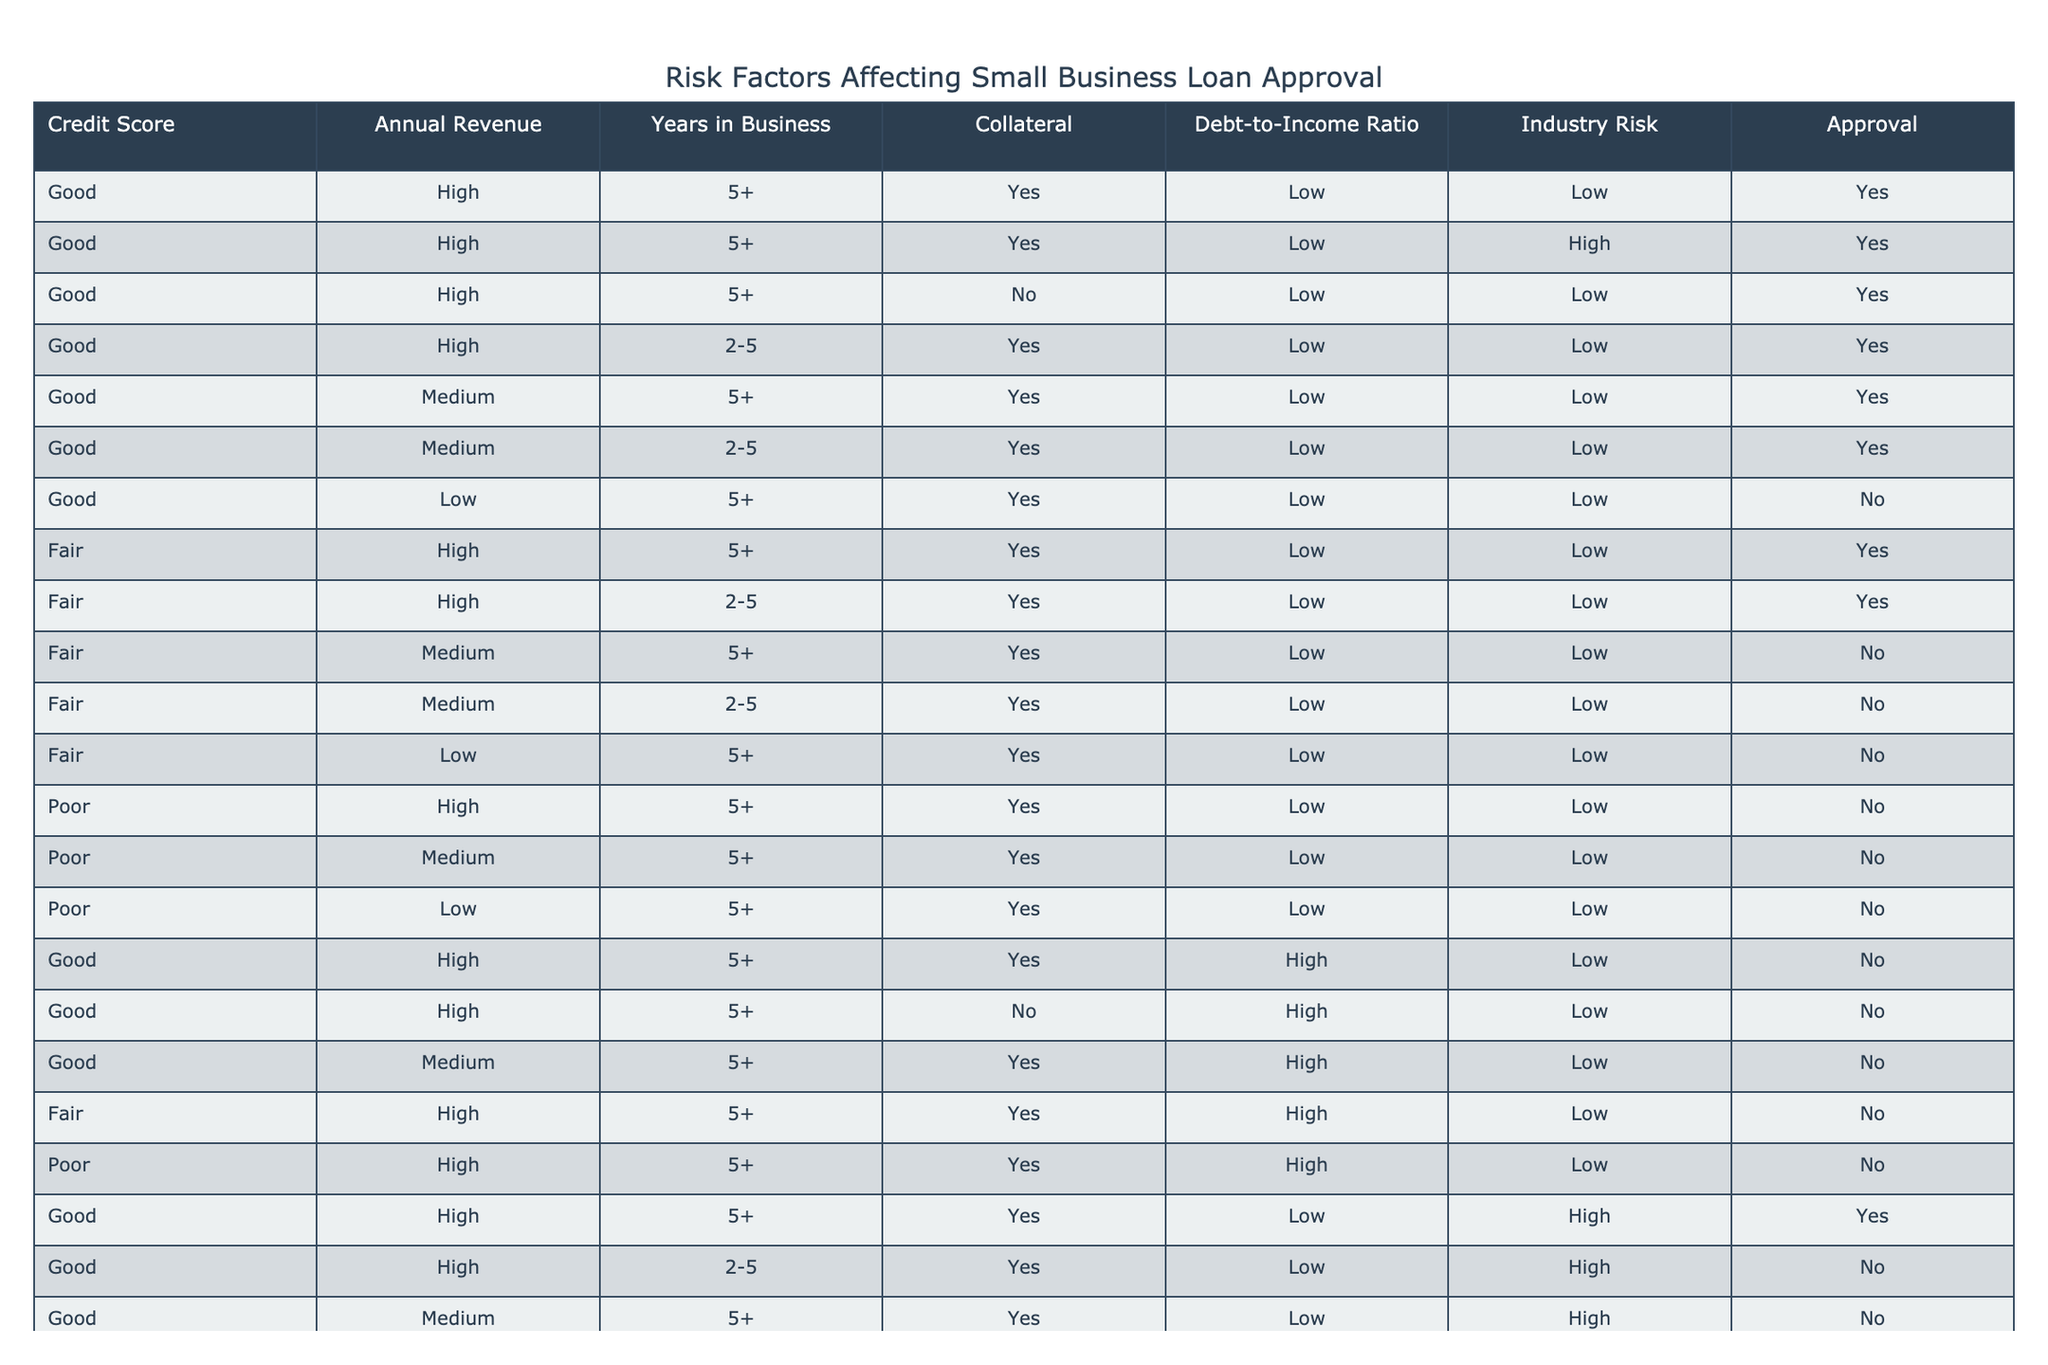What is the approval rate for businesses with a "Good" credit score? To find the approval rate, count the total number of entries with a "Good" credit score and then identify how many of those were approved. There are 12 entries with a "Good" credit score. Out of these, 9 were approved (Yes). Therefore, the approval rate is 9 out of 12, which is 75%.
Answer: 75% How many "Poor" credit score entries were approved? There are a total of 6 entries with a "Poor" credit score. By examining these entries, it's clear that none of them were approved. Thus, the count of approved entries is 0.
Answer: 0 Is having "Collateral" a strong factor in loan approvals? To analyze this, we can consider each row with "Collateral" set to Yes. There are 9 such entries, out of which 5 were approved and 4 were not. This suggests that while having collateral may help, it does not guarantee approval.
Answer: No What is the average years in business for approved loans? First, we filter for only the entries that were approved. There are 9 approved entries, and the years in business for these entries are: 5+, 5+, 5+, 2-5, 5+, 5+, 5+, 5+, and 2-5. Converting these: (5 + 5 + 5 + 4 + 5 + 5 + 5 + 5 + 4) = 43 (considering 5+ as 5 and 2-5 as 4) and there are 9 entries, so the average is 43/9 ≈ 4.78 years.
Answer: Approximately 4.78 years Which industry risk has the highest number of loans approved? By examining the industry risk associated with approved loans, we see the approved entries relate to low risk and some to high risk. Total approved entries with low risk are 7, while those with high risk are 2. Thus, low industry risk has the highest number of approvals.
Answer: Low Does a "Fair" credit score guarantee loan approval? There are 6 entries with a "Fair" credit score. Analyzing them, 3 were approved (Yes) and 3 were not (No). Therefore, a "Fair" credit score does not guarantee approval.
Answer: No What’s the total number of entries with "High" annual revenue that were approved? We need to look at the entries where the annual revenue is labeled "High." There are 6 entries with "High" revenue, and among them, 5 were approved. Adding up these approved entries gives a total of 5.
Answer: 5 What proportion of loans with "Low" debt-to-income ratio were approved? To find this, we need to check entries with a "Low" debt-to-income ratio. There are 14 such entries, and 7 out of these were approved. The proportion of approvals is therefore 7 out of 14, which simplifies to 50%.
Answer: 50% 